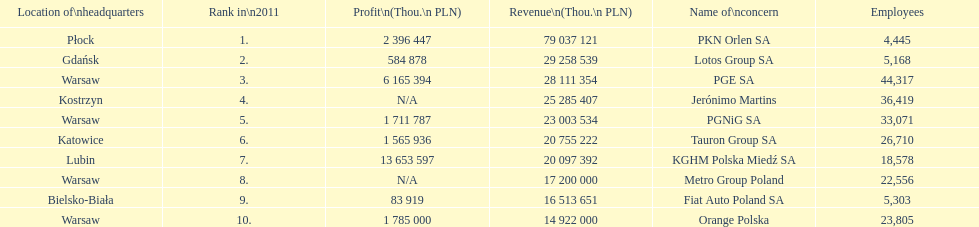Help me parse the entirety of this table. {'header': ['Location of\\nheadquarters', 'Rank in\\n2011', 'Profit\\n(Thou.\\n\xa0PLN)', 'Revenue\\n(Thou.\\n\xa0PLN)', 'Name of\\nconcern', 'Employees'], 'rows': [['Płock', '1.', '2 396 447', '79 037 121', 'PKN Orlen SA', '4,445'], ['Gdańsk', '2.', '584 878', '29 258 539', 'Lotos Group SA', '5,168'], ['Warsaw', '3.', '6 165 394', '28 111 354', 'PGE SA', '44,317'], ['Kostrzyn', '4.', 'N/A', '25 285 407', 'Jerónimo Martins', '36,419'], ['Warsaw', '5.', '1 711 787', '23 003 534', 'PGNiG SA', '33,071'], ['Katowice', '6.', '1 565 936', '20 755 222', 'Tauron Group SA', '26,710'], ['Lubin', '7.', '13 653 597', '20 097 392', 'KGHM Polska Miedź SA', '18,578'], ['Warsaw', '8.', 'N/A', '17 200 000', 'Metro Group Poland', '22,556'], ['Bielsko-Biała', '9.', '83 919', '16 513 651', 'Fiat Auto Poland SA', '5,303'], ['Warsaw', '10.', '1 785 000', '14 922 000', 'Orange Polska', '23,805']]} What is the number of employees who work for pgnig sa? 33,071. 